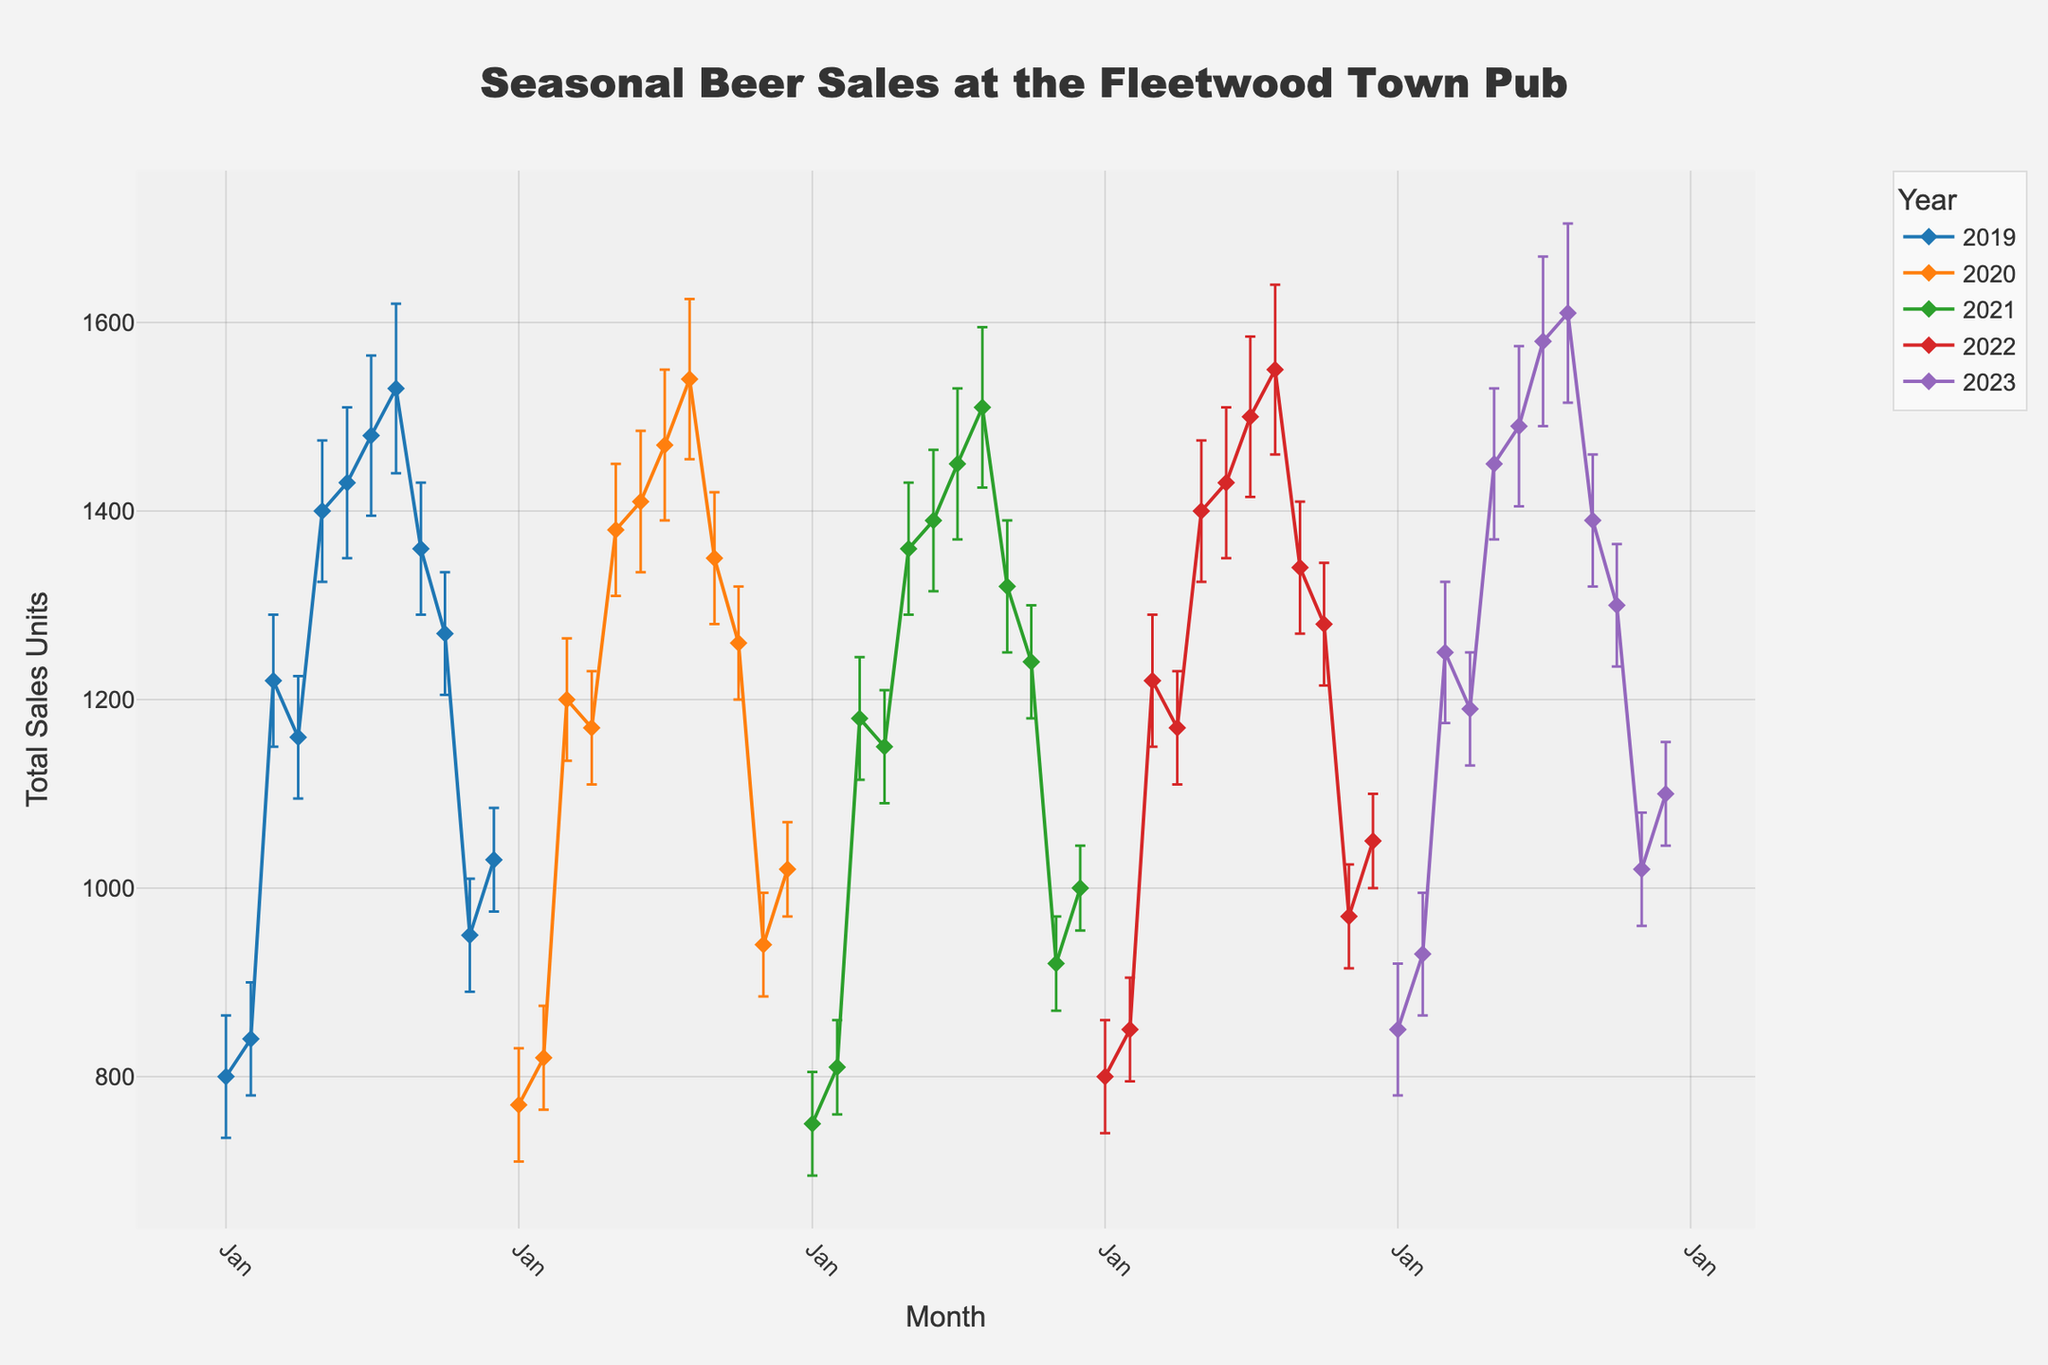How are beer sales typically varying throughout the year? By observing the line plot, we can see that beer sales generally increase starting in January, peaking in the summer months, especially in July and August, and then decreasing towards the end of the year.
Answer: Beer sales peak in summer Which month had the highest beer sales in 2023? In 2023, the data for each month shows that the month with the highest beer sales was August.
Answer: August What is the general trend of beer sales from January to December for the past 5 years? The general trend for each year shows an increase in sales from January to a peak around July or August, followed by a decrease towards December.
Answer: Increase then decrease How does the sales variability (as shown by error bars) compare between January and August? The error bars in January are smaller, indicating less variability in sales, while August has larger error bars, indicating higher variability in sales.
Answer: Higher variability in August What is the percentage increase in beer sales from January to July in 2022? In January 2022, sales were 800 units, and by July 2022, sales were 1500 units. Percentage increase = ((1500 - 800) / 800) * 100 = 87.5%.
Answer: 87.5% Which year had the most consistent (least variable) beer sales throughout all months? By comparing the size of the error bars for each year, 2019 appears to have the least variability, as the error bars are generally smaller throughout the year.
Answer: 2019 In which year did beer sales in April show the highest value? Observing the April data points for each year, 2023 had the highest beer sales in April with 1190 units.
Answer: 2023 During which month do beer sales drop the most rapidly in 2020? The largest decrease in sales between two consecutive months in 2020 is observed between September and October.
Answer: September to October Between 2019 and 2021, which year showed the highest peak sales, and in which month did it occur? Observing the peak values for each year, 2020 showed the highest peak sales of 1540 units in August.
Answer: 2020, August If a pub owner aimed to stock up on beer during the year’s highest sales month across 5 years, which month should they choose? Across the data for the past 5 years, August generally records the highest sales.
Answer: August 